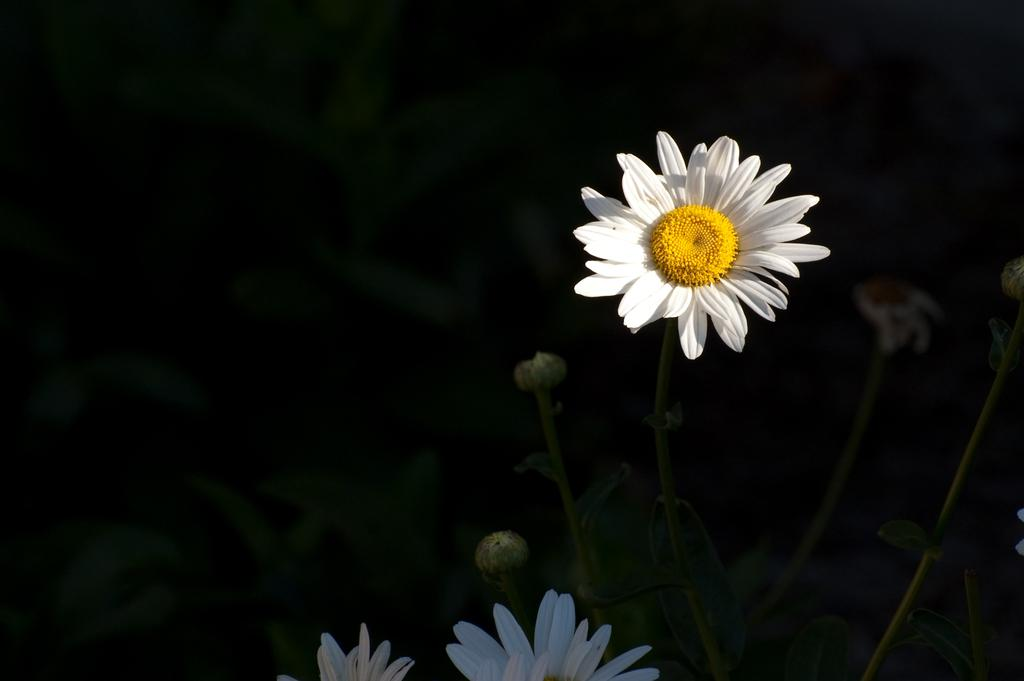What type of vegetation can be seen on the right side of the image? There are flowers and buds on the right side of the image. What else can be seen in the background of the image? There are leaves visible in the background of the image. How would you describe the color of the background in the image? The background of the image is dark. What type of soup is being served in the image? There is no soup present in the image; it features flowers, buds, and leaves. Can you tell me how many accounts are visible in the image? There are no accounts present in the image. 